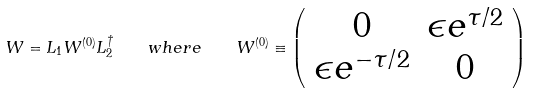<formula> <loc_0><loc_0><loc_500><loc_500>W = L _ { 1 } W ^ { ( 0 ) } L _ { 2 } ^ { \dagger } \quad w h e r e \quad W ^ { ( 0 ) } \equiv \left ( \begin{array} { c c } 0 & \epsilon e ^ { \tau / 2 } \\ \epsilon e ^ { - \tau / 2 } & 0 \end{array} \right )</formula> 